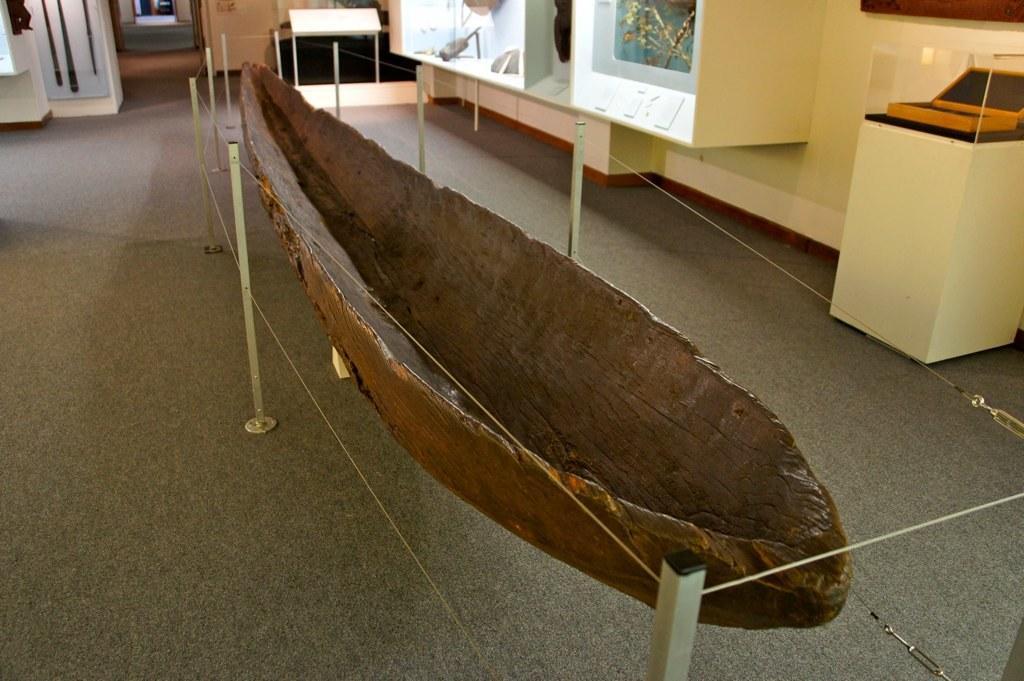In one or two sentences, can you explain what this image depicts? In this image I can see a boat in the centre and around it I can see number of poles and wires. I can also see few other stuffs in the background. 